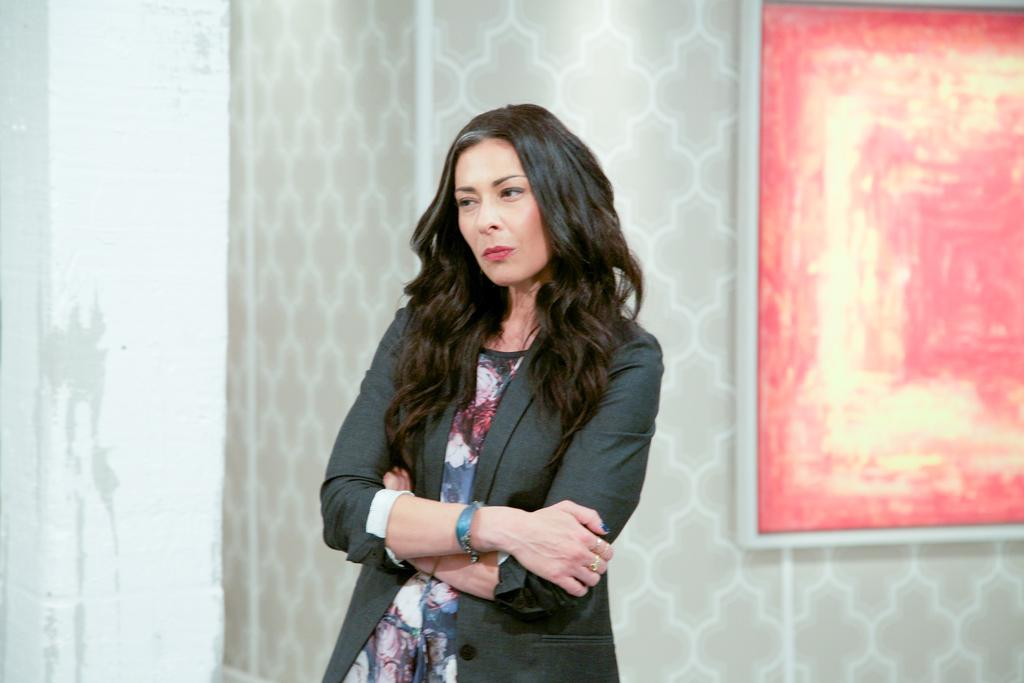What is the main subject of the image? There is a woman standing in the image. Can you describe anything on the wall in the image? There is a frame on the wall on the right side of the image. What type of vase can be seen in the image? There is no vase present in the image. What season is depicted in the image? The image does not depict a specific season, so it cannot be determined from the image. 